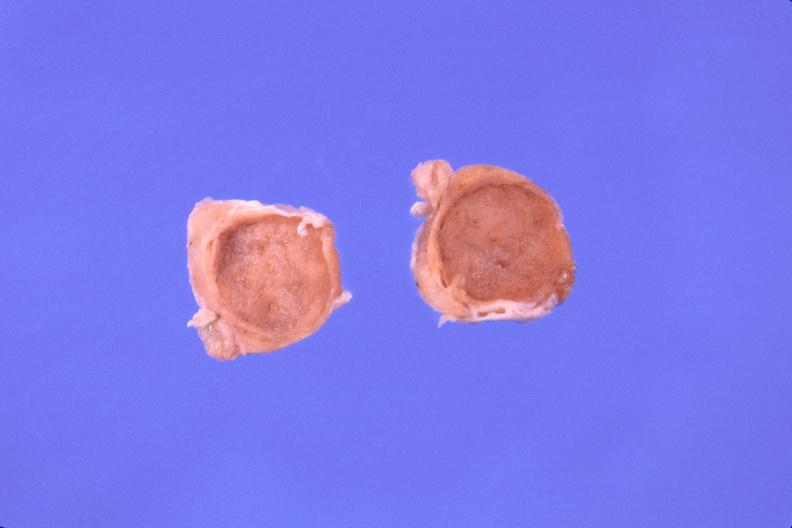does this image show pituitary, chromaphobe adenoma?
Answer the question using a single word or phrase. Yes 